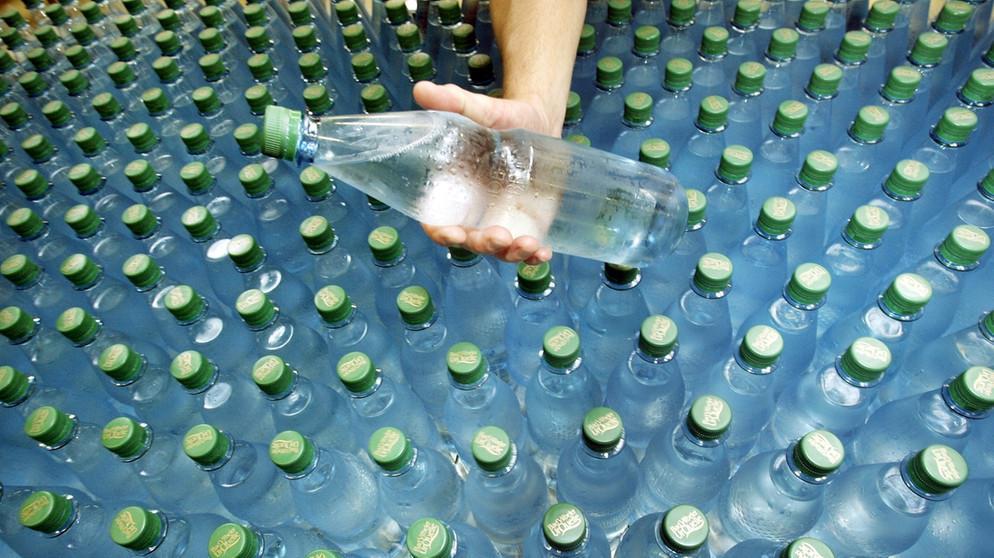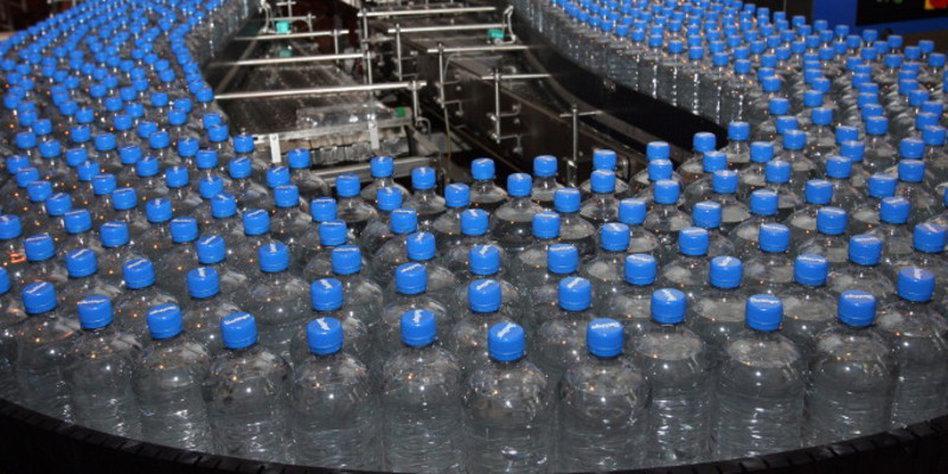The first image is the image on the left, the second image is the image on the right. For the images displayed, is the sentence "An image shows water that is not inside a bottle." factually correct? Answer yes or no. No. 